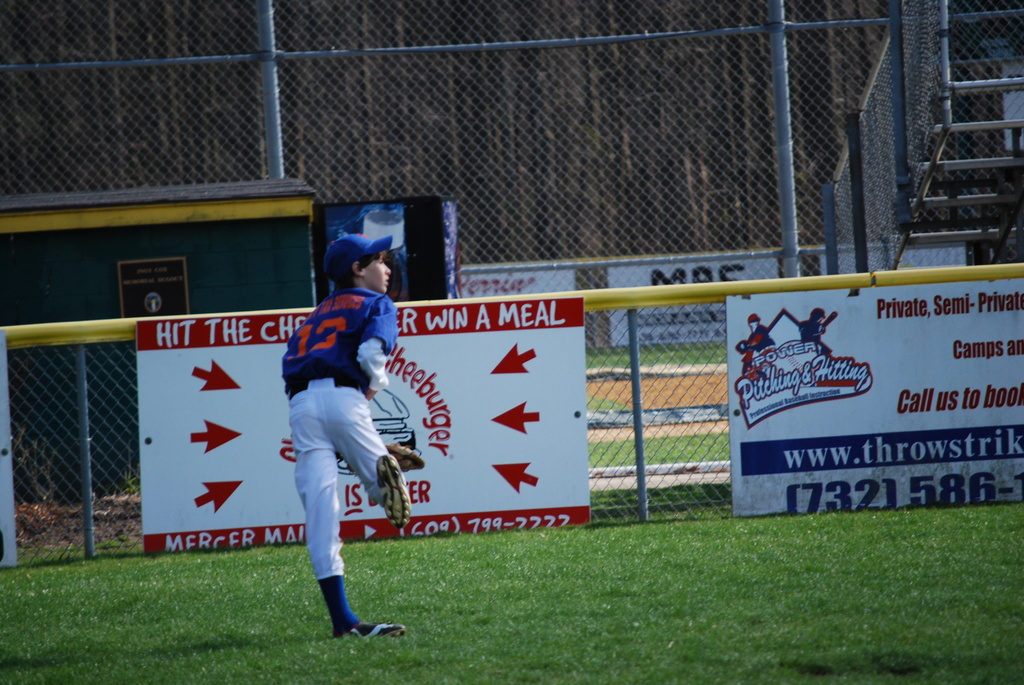Can you describe the importance of the location and design of the advertisement signs in sports venues? Advertisement signs in sports venues are strategically placed to capture the attention of spectators and television audiences, often positioned along outfield walls or near high-traffic areas. Their design is bold and eye-catching to effectively deliver the sponsor's message and ensure high visibility during key moments of the game. 